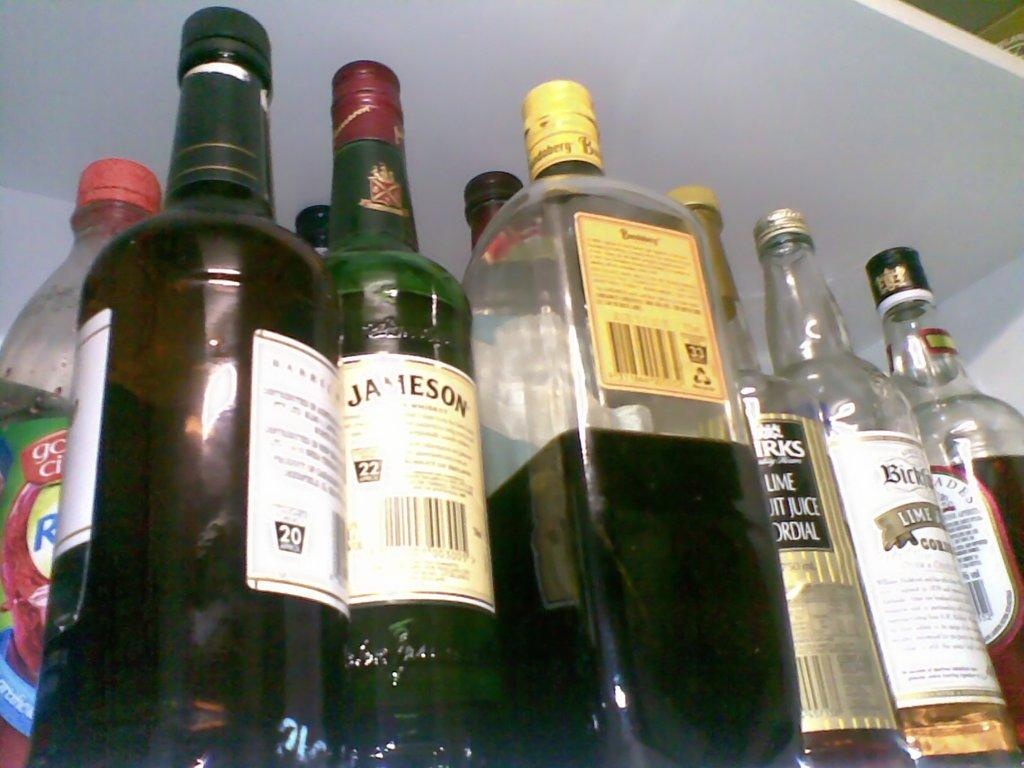<image>
Create a compact narrative representing the image presented. A bottle of Jameson is surrounded by six other bottles of various liquors. 